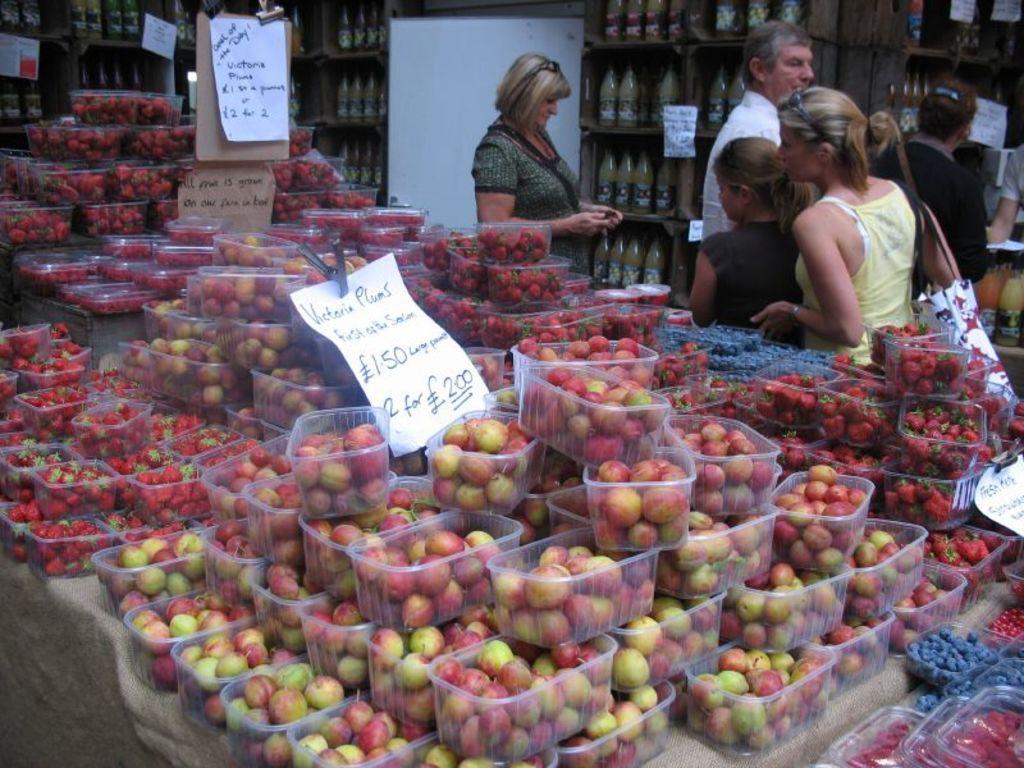In one or two sentences, can you explain what this image depicts? In this image we can see boxes with fruits. Also there are papers with text. And we can see few people. One lady is wearing a bag. In the back we can see bottles in the racks. 